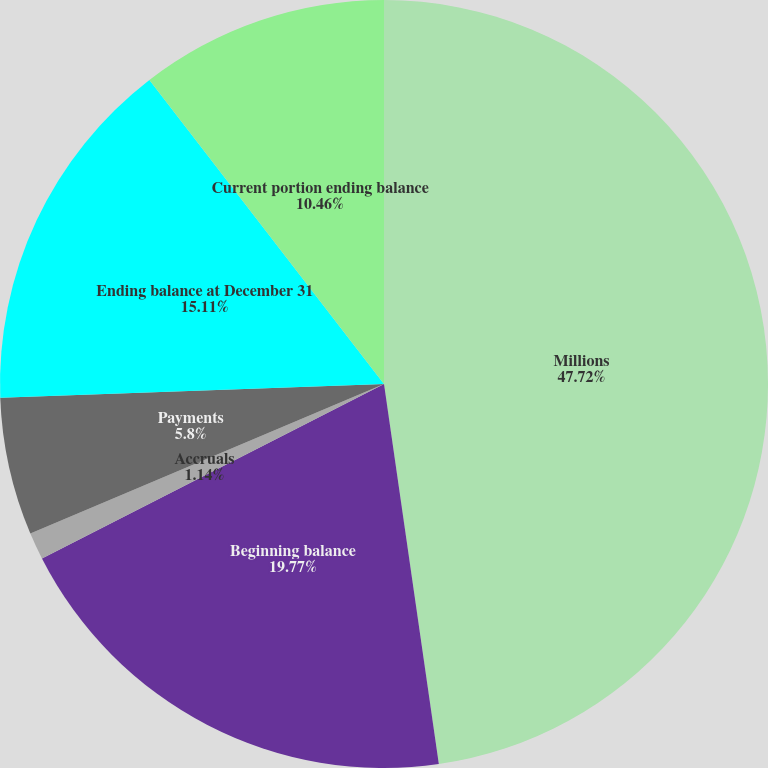Convert chart to OTSL. <chart><loc_0><loc_0><loc_500><loc_500><pie_chart><fcel>Millions<fcel>Beginning balance<fcel>Accruals<fcel>Payments<fcel>Ending balance at December 31<fcel>Current portion ending balance<nl><fcel>47.72%<fcel>19.77%<fcel>1.14%<fcel>5.8%<fcel>15.11%<fcel>10.46%<nl></chart> 